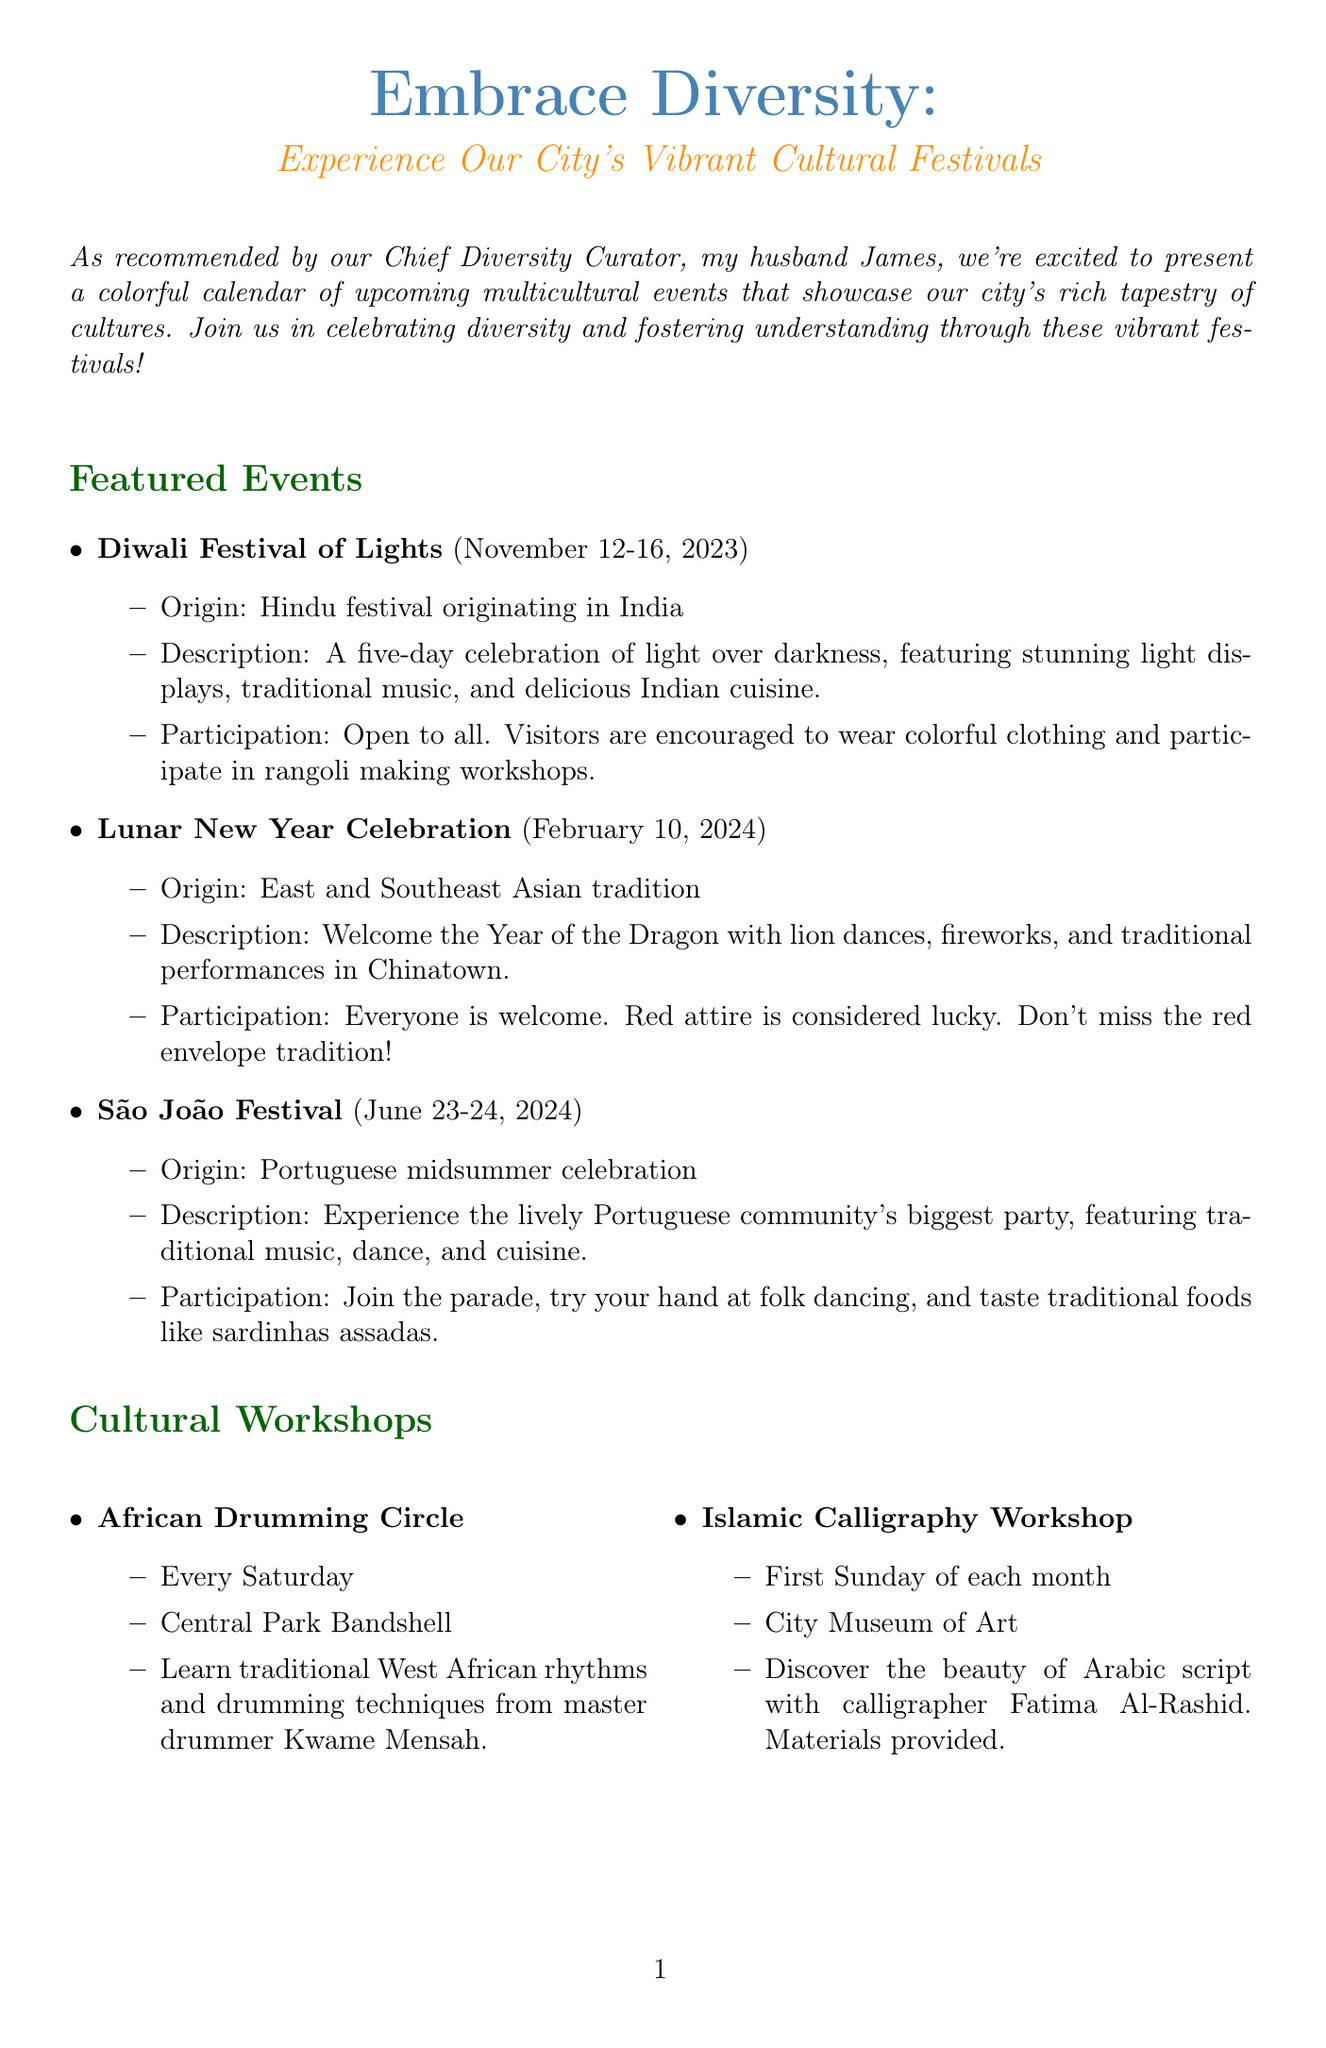What is the title of the newsletter? The title of the newsletter is provided at the beginning, summarizing the theme of celebrating diversity through cultural festivals.
Answer: Embrace Diversity: Experience Our City's Vibrant Cultural Festivals Who recommended the newsletter's content? The newsletter mentions a recommendation from a specific individual, highlighting their contribution to the event's curation.
Answer: Chief Diversity Curator, James When is the Diwali Festival of Lights? The specific dates for the Diwali Festival are listed in the featured events section of the document.
Answer: November 12-16, 2023 What is the origin of the Lunar New Year Celebration? The origin of the Lunar New Year Celebration is stated in the event details, associating it with a specific cultural tradition.
Answer: East and Southeast Asian tradition What activity is encouraged at the Diwali Festival? The participation guidelines for the Diwali Festival mention an engaging activity for visitors to join, reflecting cultural practices.
Answer: Rangoli making workshops How often does the African Drumming Circle take place? The frequency of the African Drumming Circle is mentioned in the cultural workshops section, indicating the regularity of this event.
Answer: Every Saturday What is the name of the initiative focusing on culinary experiences? The diversity initiatives section includes a specific program dedicated to exploring the city's diverse food scene, specifically curated for this purpose.
Answer: Multicultural Food Tour What is the location of the Islamic Calligraphy Workshop? The document specifies the exact venue for the Islamic Calligraphy Workshop, providing clear information on its location.
Answer: City Museum of Art What does participating in these events allow tourists to do? The closing statement emphasizes the value of participation for visitors, highlighting the benefits of engagement with local culture.
Answer: Become part of our global community 